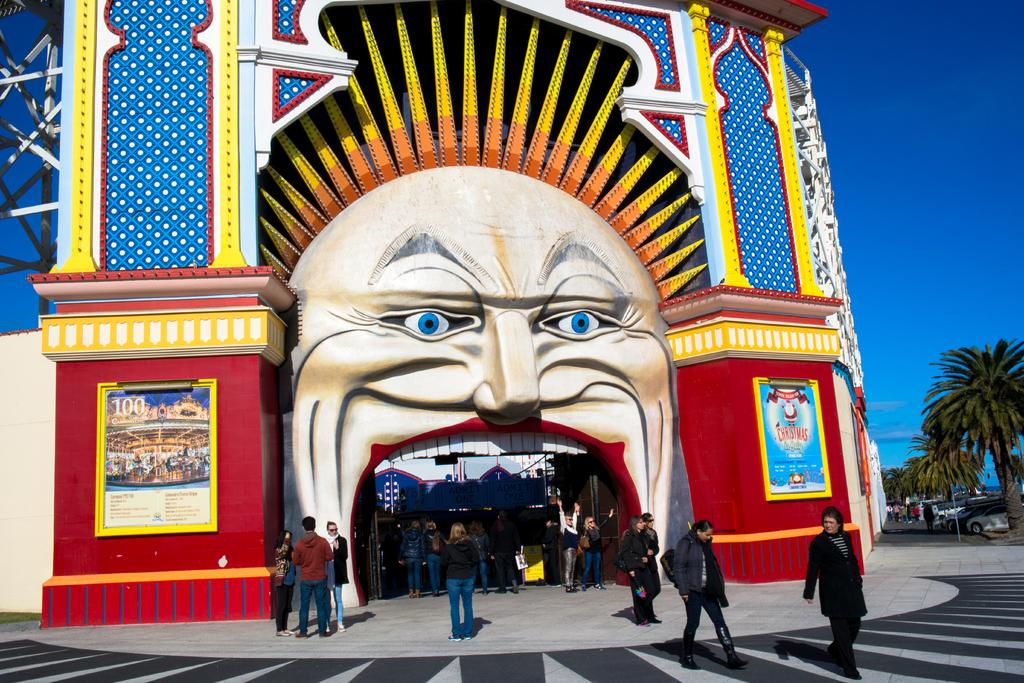What can be seen on the ground in the image? There are people on the ground in the image. What is located on the right side of the image? There are vehicles and trees on the right side of the image. What is visible in the background of the image? The sky is visible in the background of the image. Can you see a mitten being used by someone in the image? There is no mitten present in the image. Is this a family gathering, based on the people in the image? The image does not provide enough information to determine if it is a family gathering or not. 